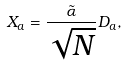Convert formula to latex. <formula><loc_0><loc_0><loc_500><loc_500>X _ { a } = \frac { \tilde { \alpha } } { \sqrt { N } } D _ { a } ,</formula> 